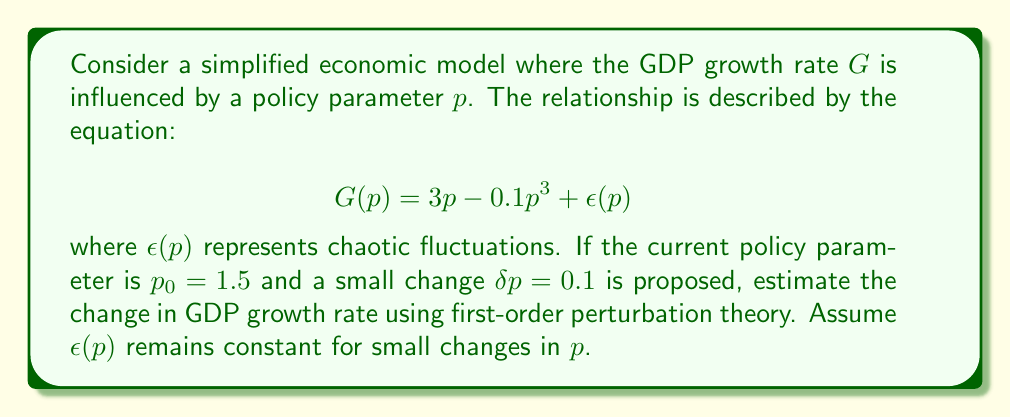Give your solution to this math problem. To solve this problem using perturbation theory, we follow these steps:

1) The first-order perturbation approximation is given by:

   $$\Delta G \approx \frac{dG}{dp}\bigg|_{p=p_0} \cdot \delta p$$

2) To find $\frac{dG}{dp}$, we differentiate $G(p)$ with respect to $p$:

   $$\frac{dG}{dp} = 3 - 0.3p^2 + \frac{d\epsilon}{dp}$$

3) Since we assume $\epsilon(p)$ remains constant for small changes, $\frac{d\epsilon}{dp} = 0$. So:

   $$\frac{dG}{dp} = 3 - 0.3p^2$$

4) Evaluate this at $p_0 = 1.5$:

   $$\frac{dG}{dp}\bigg|_{p=p_0} = 3 - 0.3(1.5)^2 = 3 - 0.3(2.25) = 3 - 0.675 = 2.325$$

5) Now we can estimate the change in GDP growth rate:

   $$\Delta G \approx 2.325 \cdot 0.1 = 0.2325$$

This means the GDP growth rate is estimated to increase by approximately 0.2325 percentage points.
Answer: 0.2325 percentage points 